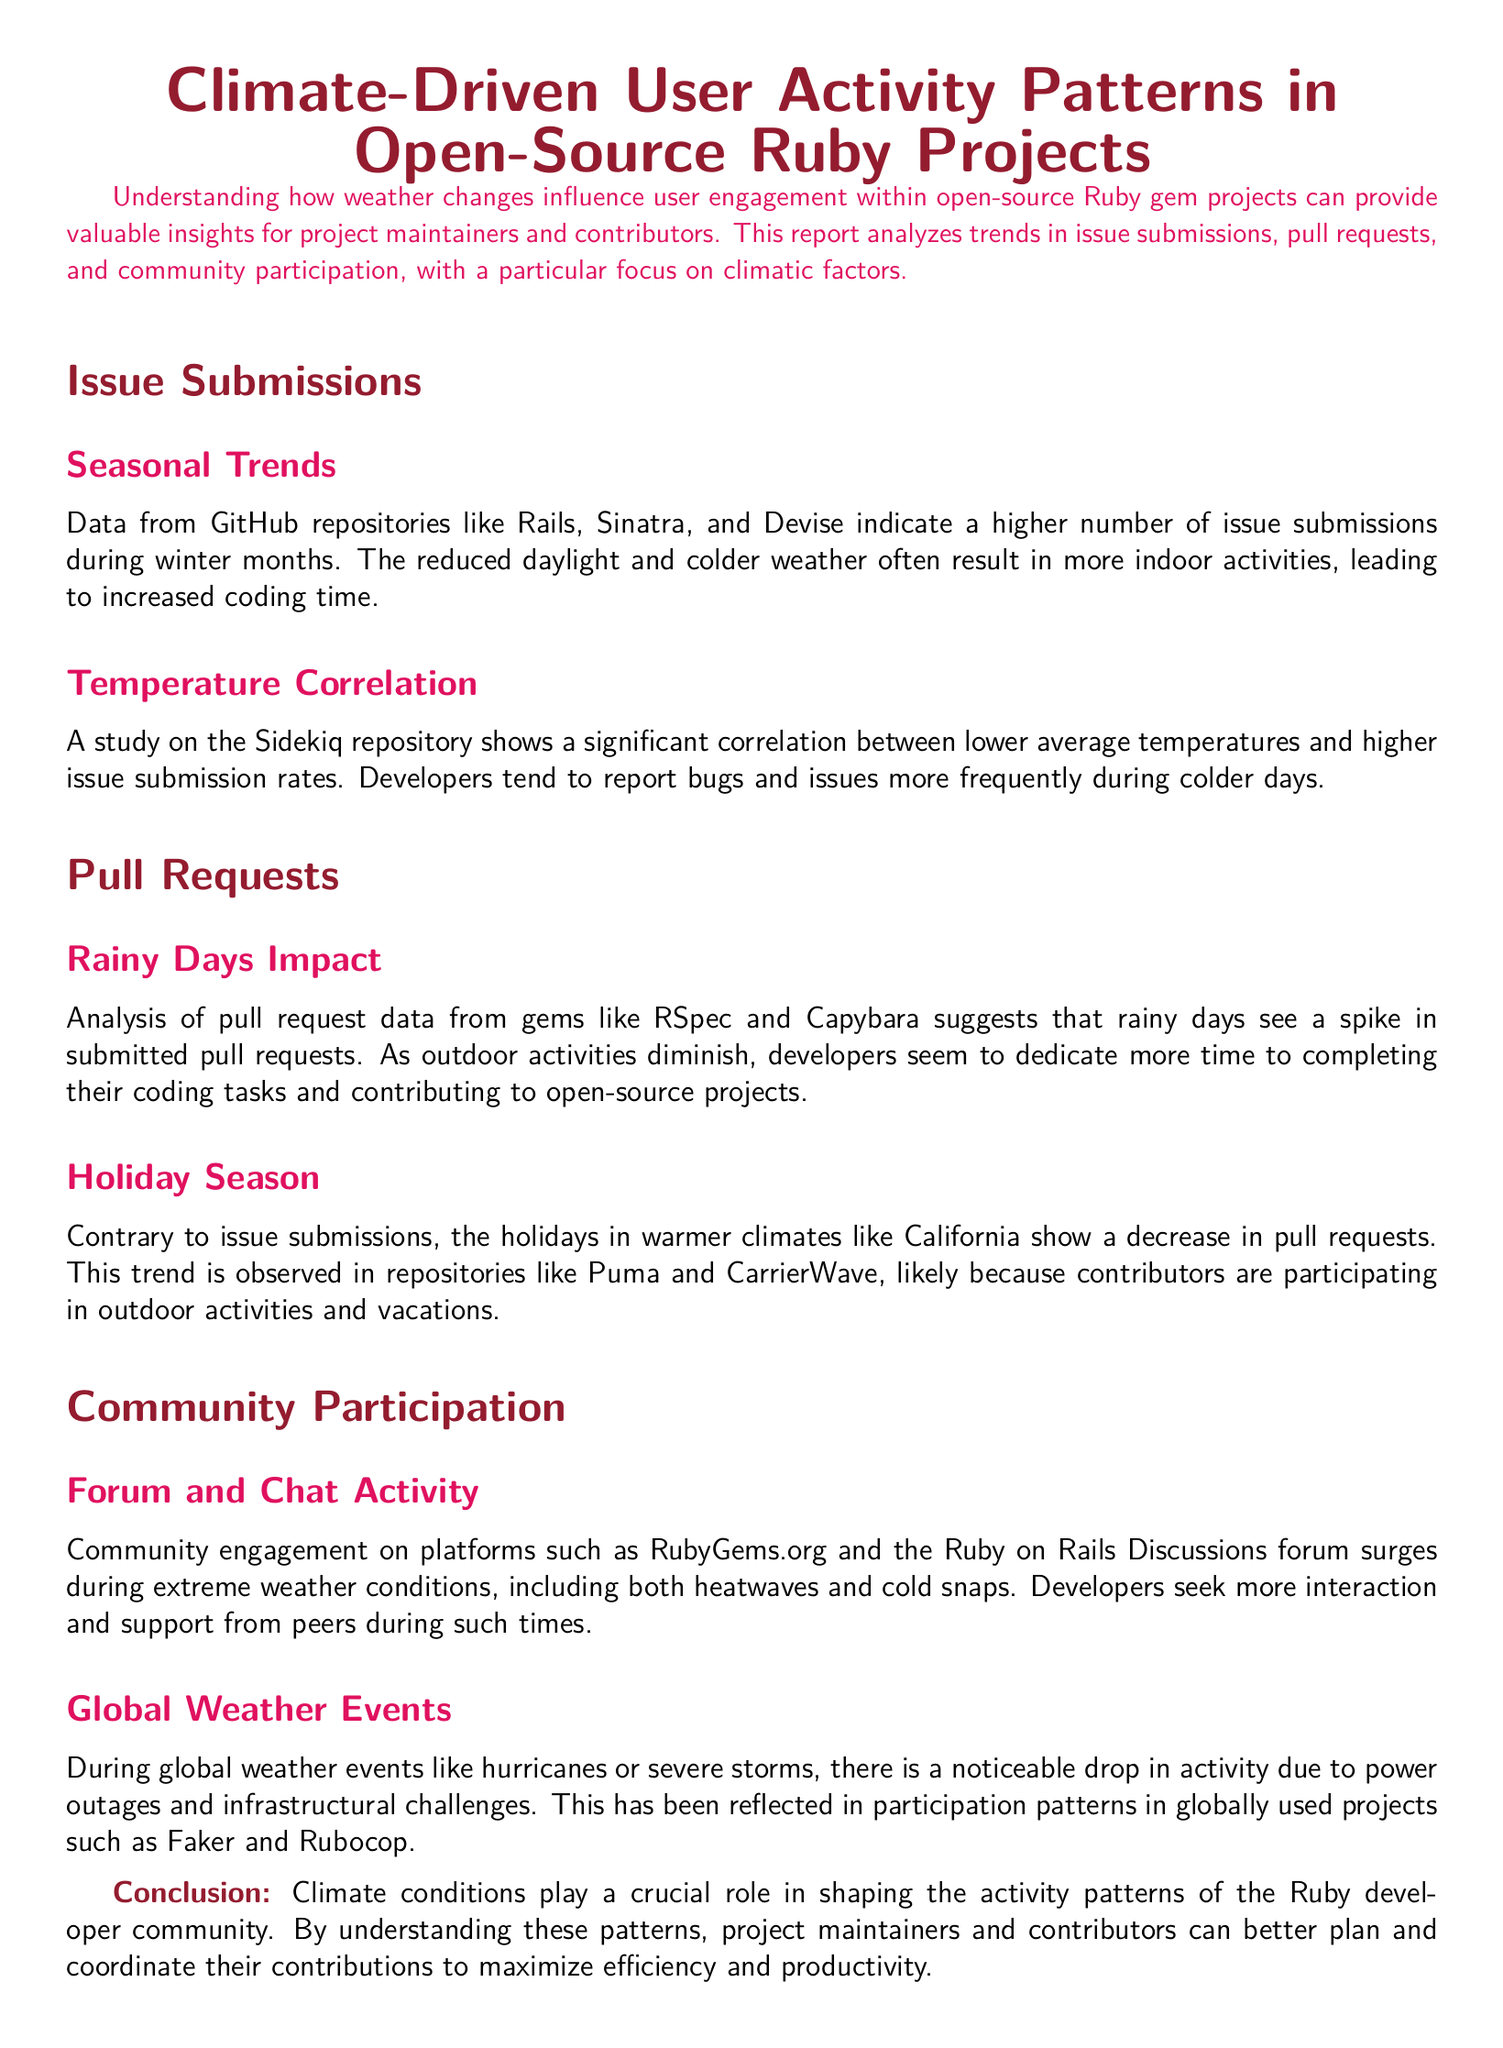what is the primary focus of this report? The report focuses on the analysis of how weather changes influence user engagement and interaction with open-source projects.
Answer: Weather changes influence user engagement which repositories show higher issue submissions during winter? Data from GitHub repositories indicate that Rails, Sinatra, and Devise show higher issue submissions during winter months.
Answer: Rails, Sinatra, and Devise what climatic condition correlates with increased issue submission rates? The study mentions that lower average temperatures correlate with higher issue submission rates.
Answer: Lower average temperatures how do rainy days affect pull requests? The analysis indicates that rainy days see a spike in submitted pull requests.
Answer: Spike in submitted pull requests what effect do holidays in warmer climates have on pull requests? The holidays in warmer climates like California show a decrease in pull requests, due to outdoor activities.
Answer: Decrease in pull requests how does extreme weather affect community engagement? Community engagement surges during extreme weather conditions, including both heatwaves and cold snaps.
Answer: Surges during extreme weather what happens to activity patterns during global weather events? There is a noticeable drop in activity during global weather events like hurricanes or severe storms.
Answer: Drop in activity who benefits from understanding climate-driven user activity patterns? Project maintainers and contributors benefit from understanding these activity patterns to coordinate their contributions.
Answer: Project maintainers and contributors 